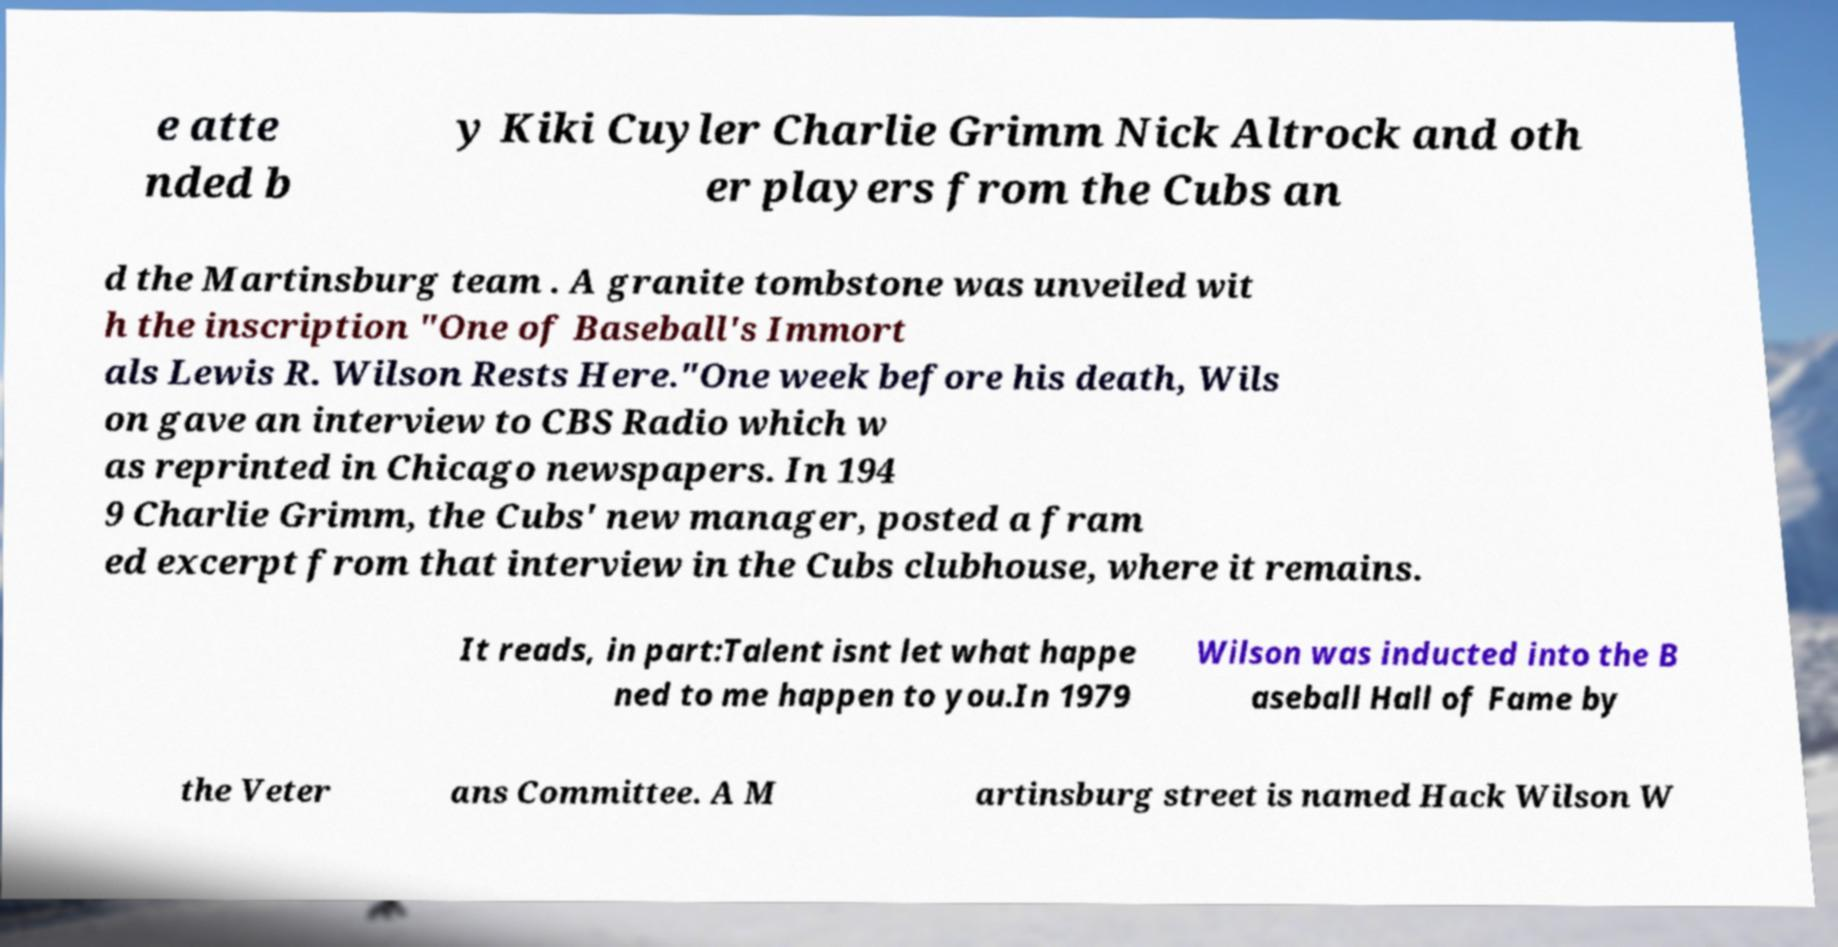There's text embedded in this image that I need extracted. Can you transcribe it verbatim? e atte nded b y Kiki Cuyler Charlie Grimm Nick Altrock and oth er players from the Cubs an d the Martinsburg team . A granite tombstone was unveiled wit h the inscription "One of Baseball's Immort als Lewis R. Wilson Rests Here."One week before his death, Wils on gave an interview to CBS Radio which w as reprinted in Chicago newspapers. In 194 9 Charlie Grimm, the Cubs' new manager, posted a fram ed excerpt from that interview in the Cubs clubhouse, where it remains. It reads, in part:Talent isnt let what happe ned to me happen to you.In 1979 Wilson was inducted into the B aseball Hall of Fame by the Veter ans Committee. A M artinsburg street is named Hack Wilson W 